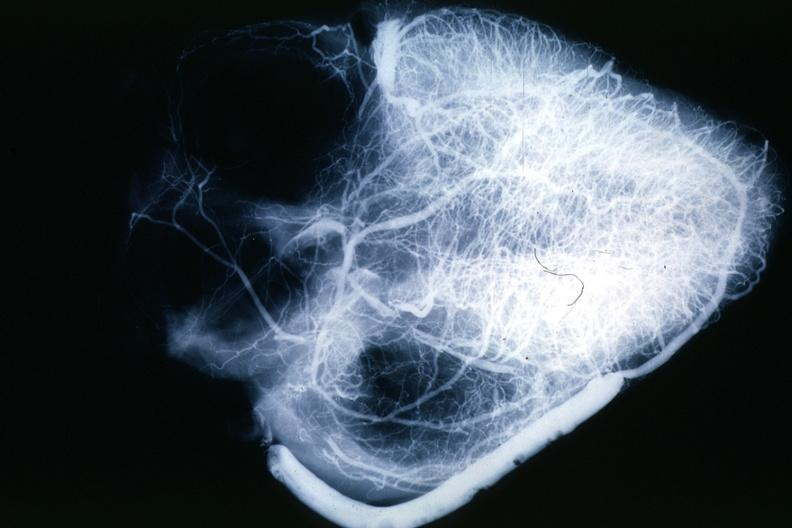s angiogram saphenous vein bypass graft present?
Answer the question using a single word or phrase. Yes 